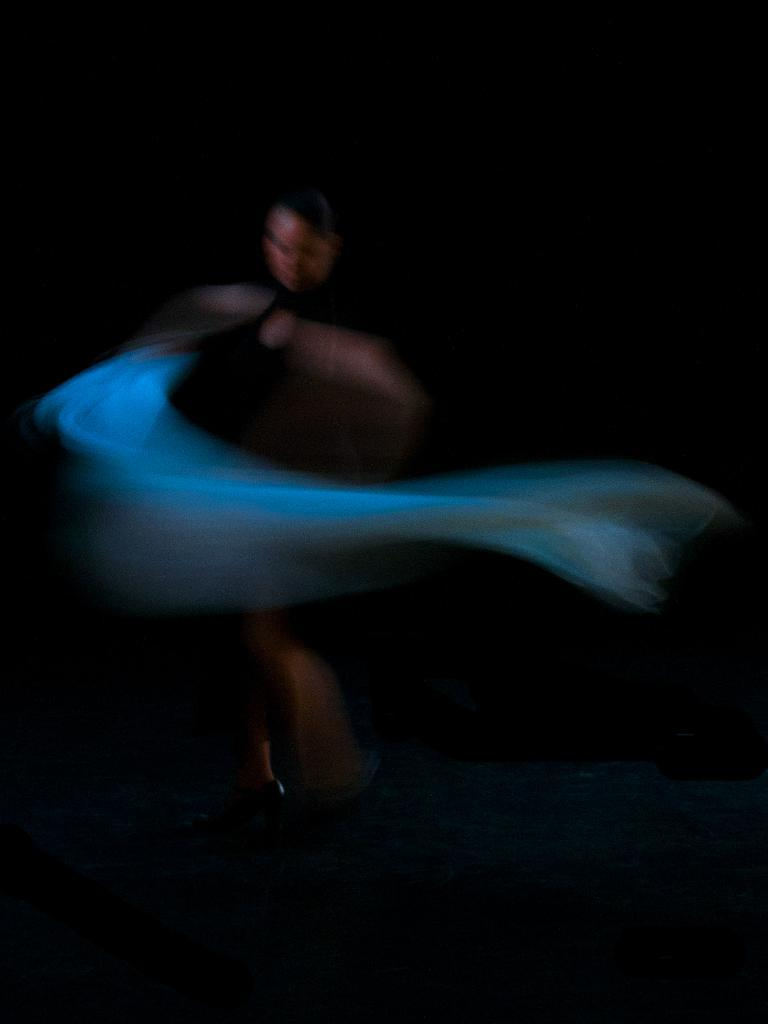Who is present in the image? There is a woman in the image. What is the woman doing in the image? The woman is standing on the floor. What object is the woman holding in the image? The woman is holding a cloth. What type of sticks can be seen being traded in the image? There are no sticks or any indication of trading in the image; it features a woman standing on the floor and holding a cloth. 